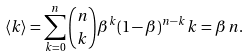<formula> <loc_0><loc_0><loc_500><loc_500>\langle k \rangle = \sum _ { k = 0 } ^ { n } { n \choose k } \beta ^ { k } ( 1 - \beta ) ^ { n - k } \, k = \beta \, n .</formula> 